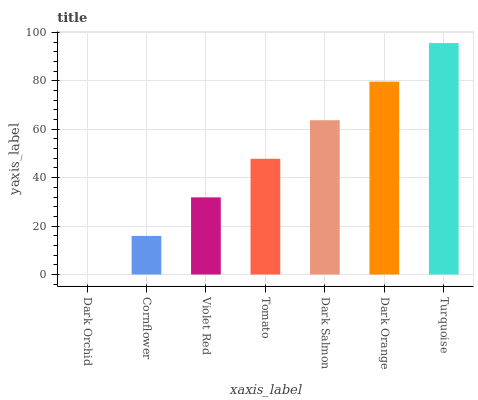Is Dark Orchid the minimum?
Answer yes or no. Yes. Is Turquoise the maximum?
Answer yes or no. Yes. Is Cornflower the minimum?
Answer yes or no. No. Is Cornflower the maximum?
Answer yes or no. No. Is Cornflower greater than Dark Orchid?
Answer yes or no. Yes. Is Dark Orchid less than Cornflower?
Answer yes or no. Yes. Is Dark Orchid greater than Cornflower?
Answer yes or no. No. Is Cornflower less than Dark Orchid?
Answer yes or no. No. Is Tomato the high median?
Answer yes or no. Yes. Is Tomato the low median?
Answer yes or no. Yes. Is Dark Orange the high median?
Answer yes or no. No. Is Violet Red the low median?
Answer yes or no. No. 